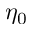<formula> <loc_0><loc_0><loc_500><loc_500>\eta _ { 0 }</formula> 